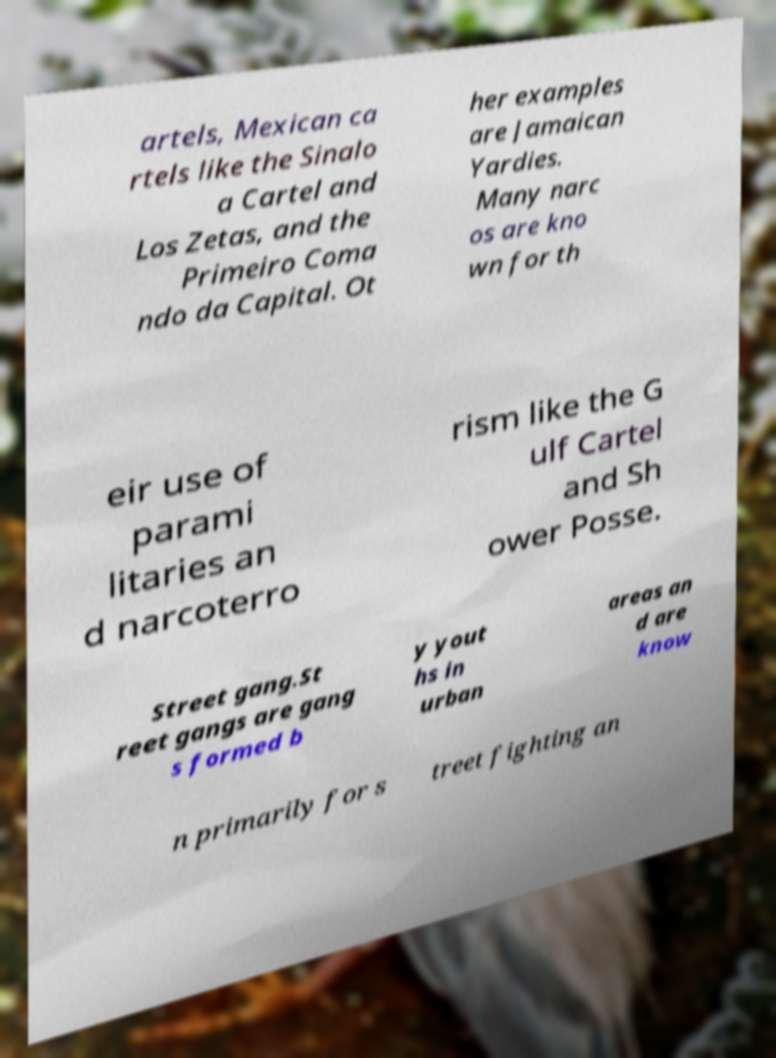Please identify and transcribe the text found in this image. artels, Mexican ca rtels like the Sinalo a Cartel and Los Zetas, and the Primeiro Coma ndo da Capital. Ot her examples are Jamaican Yardies. Many narc os are kno wn for th eir use of parami litaries an d narcoterro rism like the G ulf Cartel and Sh ower Posse. Street gang.St reet gangs are gang s formed b y yout hs in urban areas an d are know n primarily for s treet fighting an 